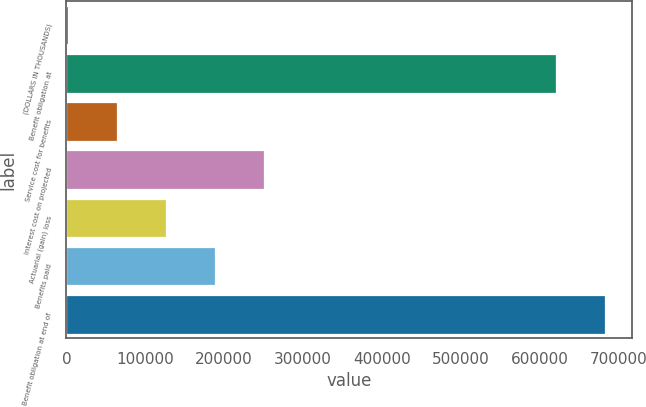<chart> <loc_0><loc_0><loc_500><loc_500><bar_chart><fcel>(DOLLARS IN THOUSANDS)<fcel>Benefit obligation at<fcel>Service cost for benefits<fcel>Interest cost on projected<fcel>Actuarial (gain) loss<fcel>Benefits paid<fcel>Benefit obligation at end of<nl><fcel>2010<fcel>621259<fcel>64314.2<fcel>251227<fcel>126618<fcel>188923<fcel>683563<nl></chart> 